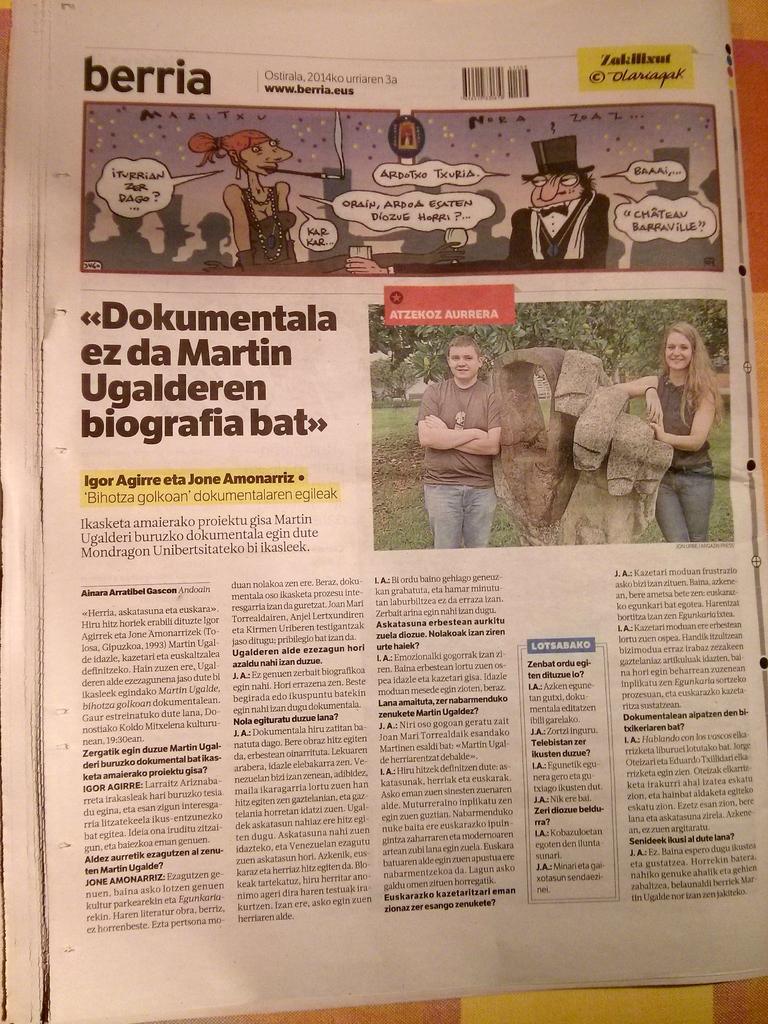How would you summarize this image in a sentence or two? In this image we can see some pictures and articles on a paper. 